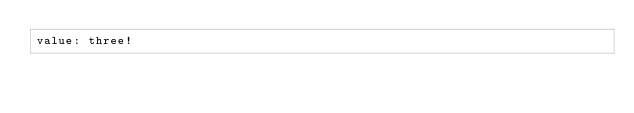<code> <loc_0><loc_0><loc_500><loc_500><_YAML_>value: three!</code> 